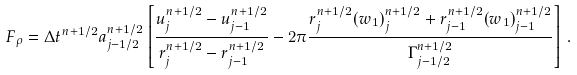Convert formula to latex. <formula><loc_0><loc_0><loc_500><loc_500>F _ { \rho } = \Delta t ^ { n + 1 / 2 } a _ { j - 1 / 2 } ^ { n + 1 / 2 } \left [ \frac { u _ { j } ^ { n + 1 / 2 } - u _ { j - 1 } ^ { n + 1 / 2 } } { r _ { j } ^ { n + 1 / 2 } - r _ { j - 1 } ^ { n + 1 / 2 } } - 2 \pi \frac { r _ { j } ^ { n + 1 / 2 } ( w _ { 1 } ) _ { j } ^ { n + 1 / 2 } + r _ { j - 1 } ^ { n + 1 / 2 } ( w _ { 1 } ) _ { j - 1 } ^ { n + 1 / 2 } } { \Gamma _ { j - 1 / 2 } ^ { n + 1 / 2 } } \right ] \, .</formula> 